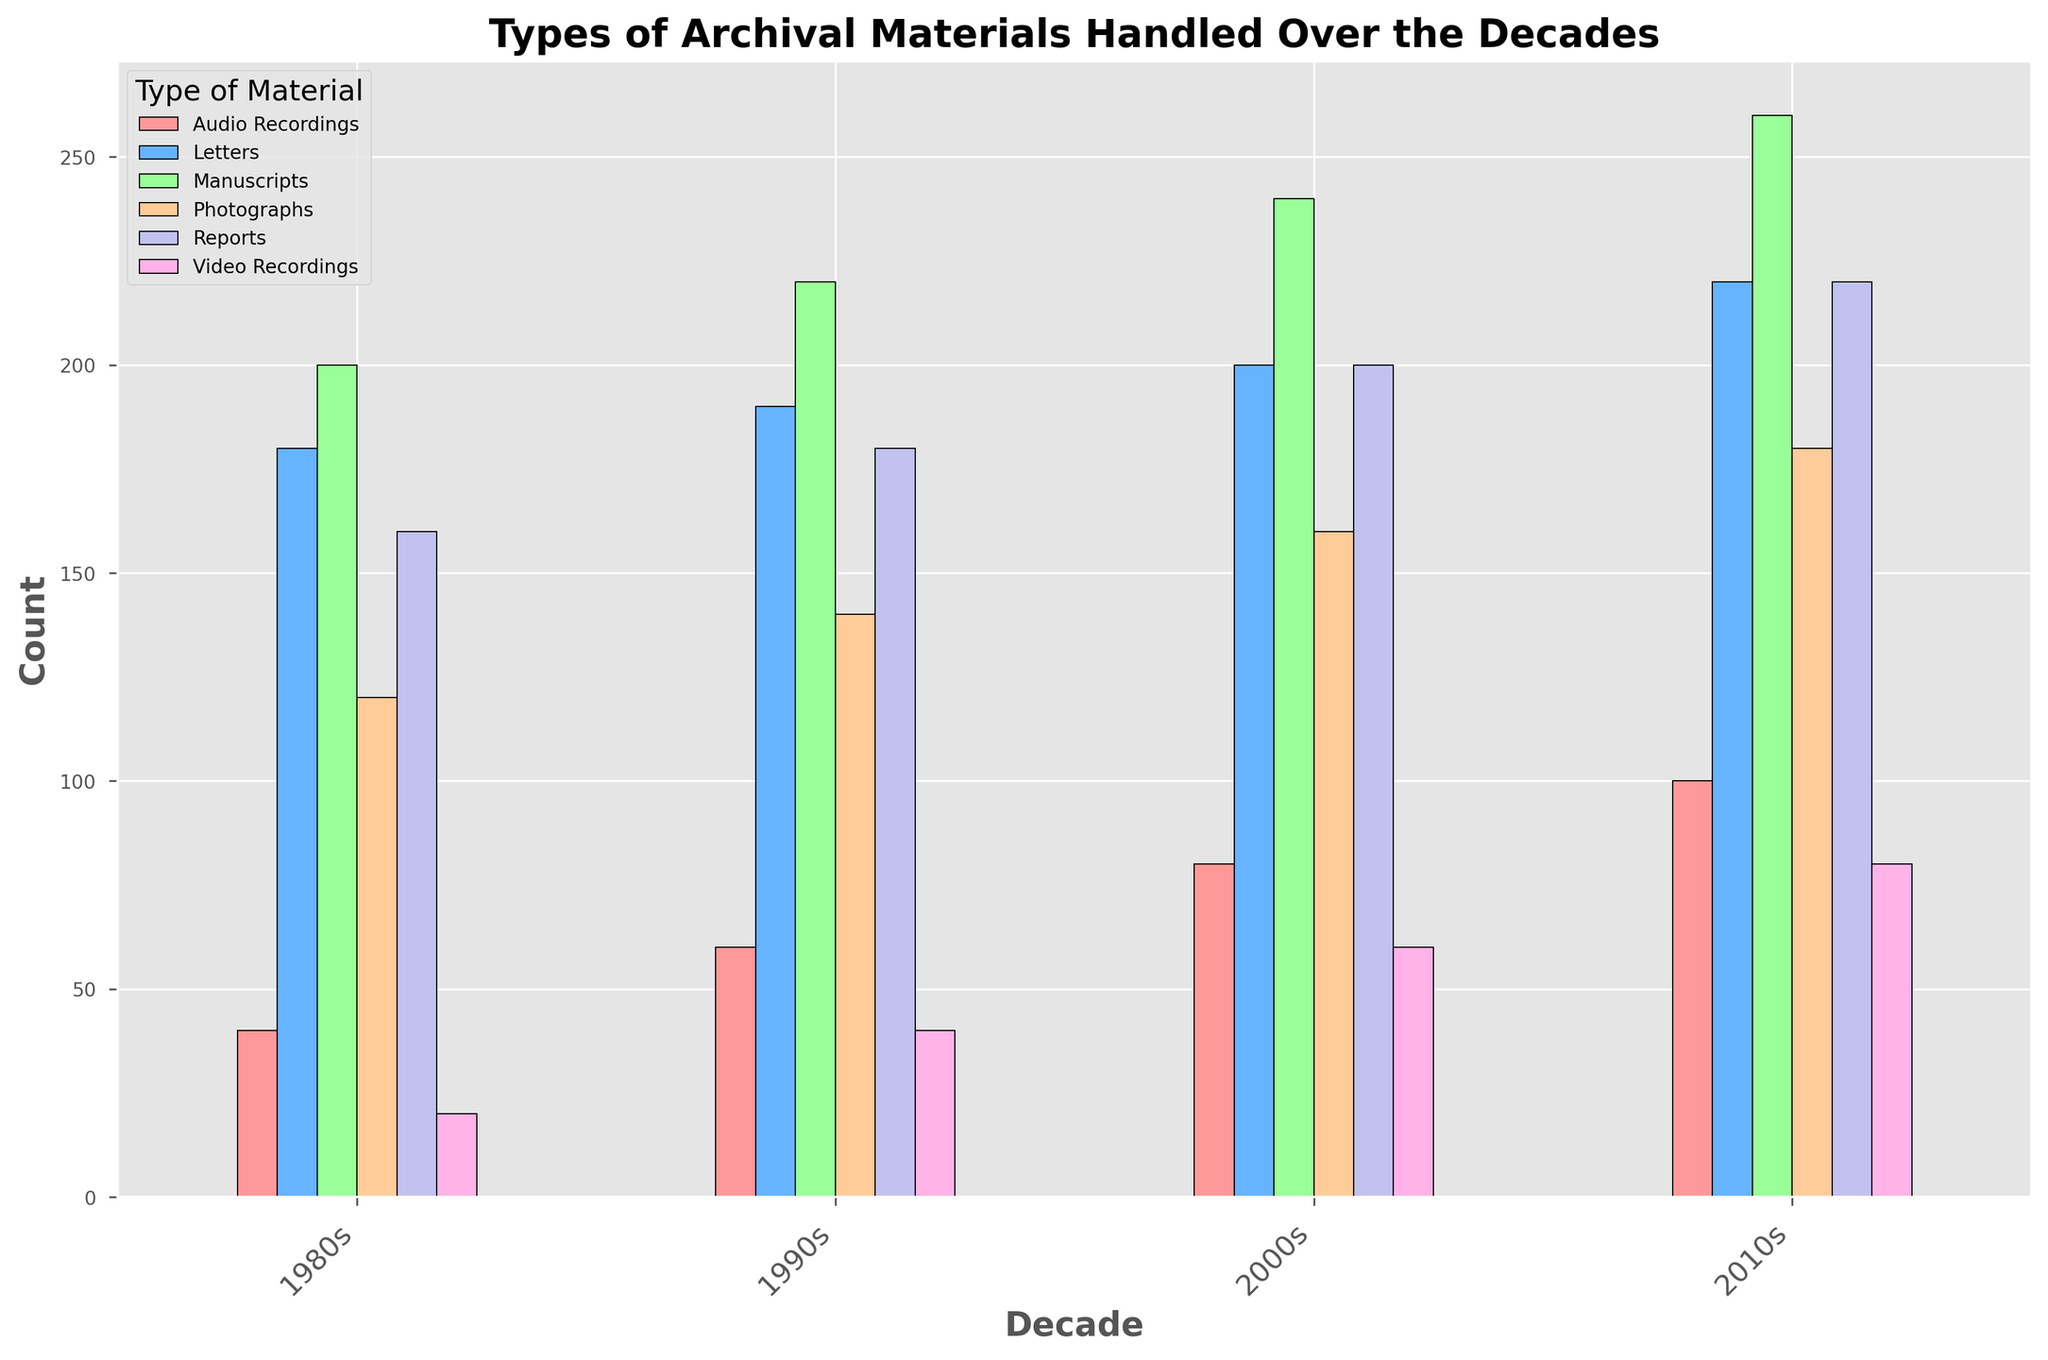What is the general trend for the count of photographs handled from the 1980s to the 2010s? The count of photographs increased steadily from 120 in the 1980s to 180 in the 2010s. This can be observed by looking at the height of the bars for photographs, which consistently rises in each subsequent decade.
Answer: Increasing Which decade had the highest count of reports handled? The decade with the highest count of reports is the 2010s, with a count of 220. This can be determined by comparing the height of the bars representing reports across each decade and noting that the highest bar appears in the 2010s.
Answer: 2010s In which decade did the count of audio recordings double compared to the previous decade? From the 1990s to the 2000s, the count of audio recordings doubled from 60 to 80. This can be seen by comparing the bars representing audio recordings (colored differently) between the respective decades.
Answer: 2000s Which type of archival material had the least count in the 1980s, and what was its count? Video recordings had the least count in the 1980s with a count of 20. This is observed by comparing the smallest bars for each type of material in the 1980s, where the bar for video recordings is the shortest.
Answer: Video recordings, 20 What is the total count of letters handled over the decades from the 1980s to the 2010s? The total count of letters is the sum of counts from each decade: 180 (1980s) + 190 (1990s) + 200 (2000s) + 220 (2010s) = 790. This is calculated by adding the values represented by the bars for letters across all decades.
Answer: 790 What is the difference in the count of manuscripts handled between the 1980s and the 2010s? The difference is obtained by subtracting the count in the 1980s from the count in the 2010s: 260 (2010s) - 200 (1980s) = 60. This can be calculated by noting the height difference between the bars representing manuscripts in these two decades.
Answer: 60 Which type of material showed the most consistent increase across all decades? Manuscripts showed the most consistent increase, with counts rising from 200 in the 1980s to 220 in the 1990s, 240 in the 2000s, and 260 in the 2010s. This is observed by noting that the bars representing manuscripts increase in height consistently with each subsequent decade.
Answer: Manuscripts What is the combined count of video recordings in the 1980s and 2010s? To find the combined count, add the counts from the 1980s and 2010s: 20 (1980s) + 80 (2010s) = 100. This can be calculated by adding the heights of the bars for video recordings in these two decades.
Answer: 100 How does the height of the bar for audio recordings in the 2000s compare to the height for the 1980s visually? The bar for audio recordings in the 2000s is twice as high as the bar for the 1980s, as the count doubled from 40 (1980s) to 80 (2000s). This can be seen by comparing the relative heights of the bars for audio recordings between these two decades.
Answer: Twice as high 